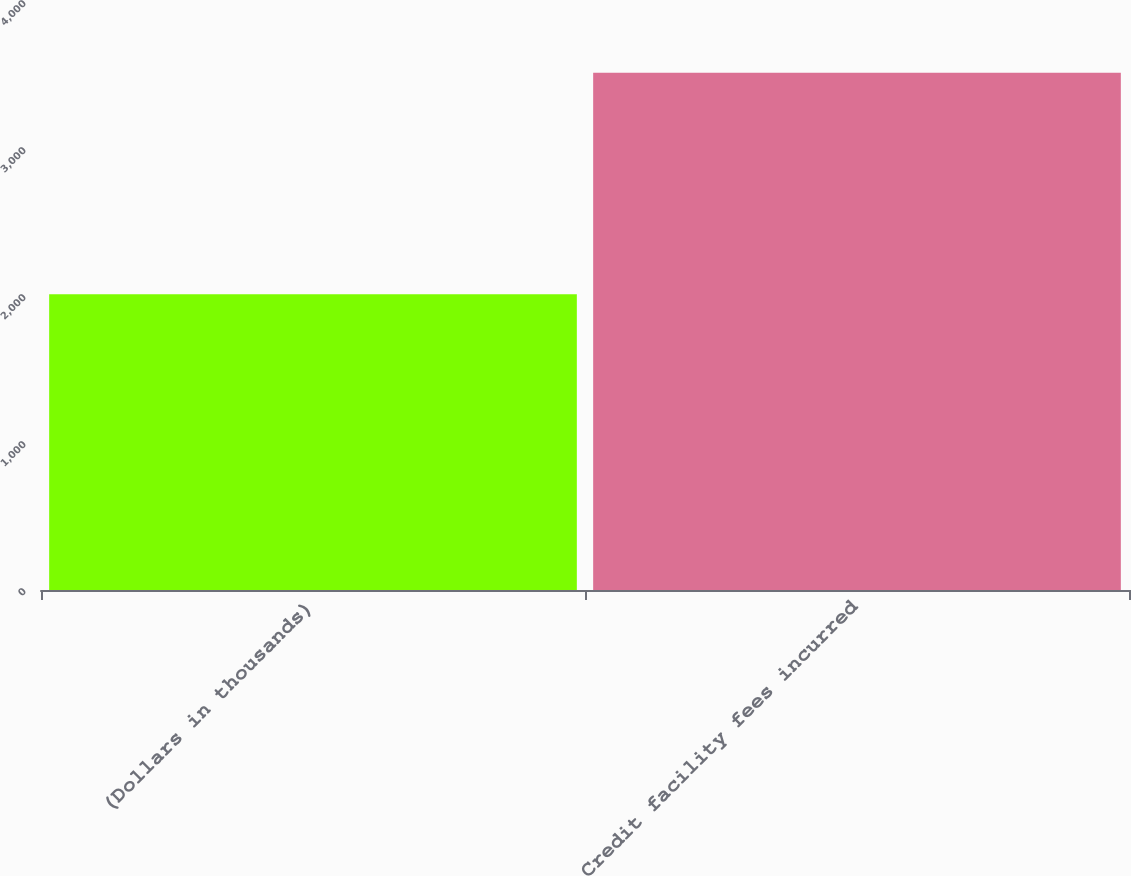<chart> <loc_0><loc_0><loc_500><loc_500><bar_chart><fcel>(Dollars in thousands)<fcel>Credit facility fees incurred<nl><fcel>2012<fcel>3519<nl></chart> 